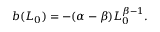<formula> <loc_0><loc_0><loc_500><loc_500>\begin{array} { r } { b ( L _ { 0 } ) = - ( \alpha - \beta ) L _ { 0 } ^ { \beta - 1 } . } \end{array}</formula> 